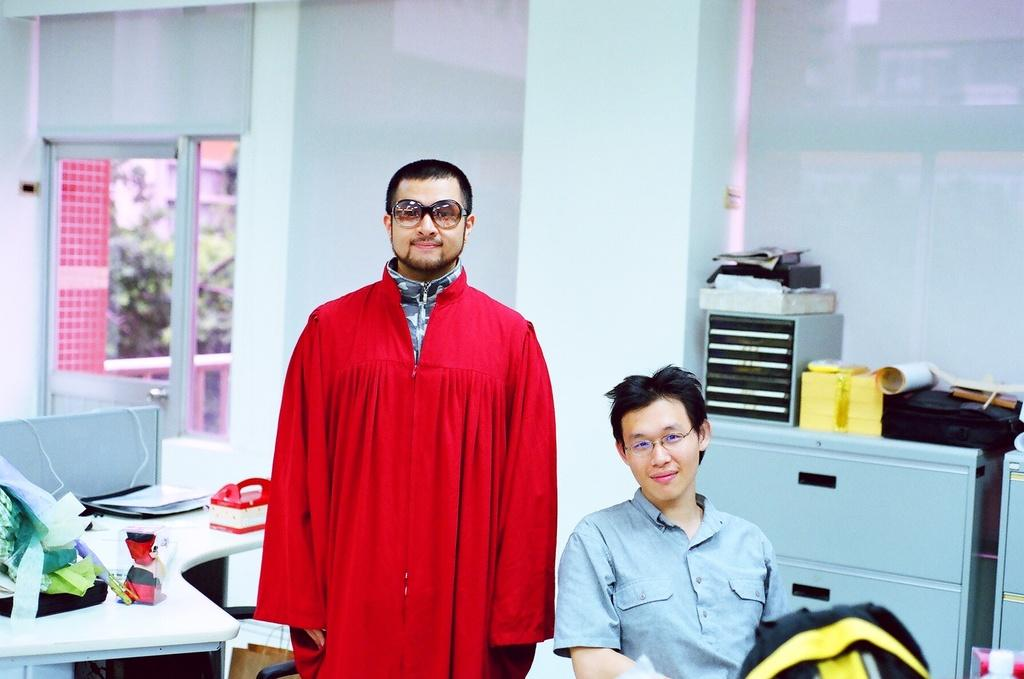How many people are in the room? There are two men in the room. What are the positions of the two men in the room? One man is standing, and the other is sitting. What furniture is present in the room? There is a table in the room. What can be found on the table? There is stuff on the table. What type of tree can be seen through the window in the room? There is no window or tree mentioned in the facts, so it is not possible to answer that question. 